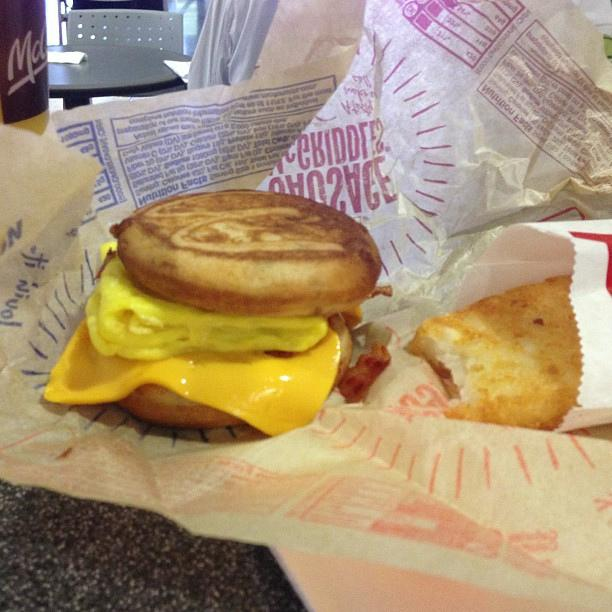What is the yellow item near the egg?

Choices:
A) corn muffin
B) cheese
C) canary
D) lemon cheese 